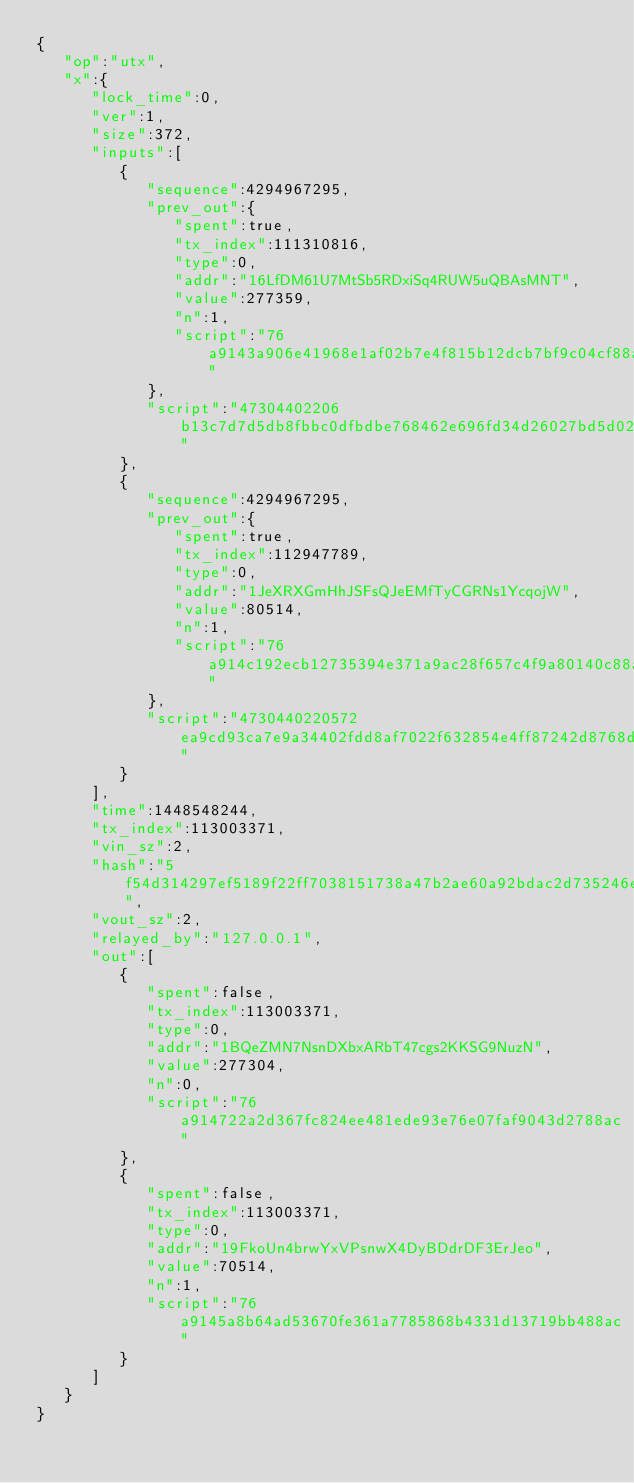Convert code to text. <code><loc_0><loc_0><loc_500><loc_500><_XML_>{
   "op":"utx",
   "x":{
      "lock_time":0,
      "ver":1,
      "size":372,
      "inputs":[
         {
            "sequence":4294967295,
            "prev_out":{
               "spent":true,
               "tx_index":111310816,
               "type":0,
               "addr":"16LfDM61U7MtSb5RDxiSq4RUW5uQBAsMNT",
               "value":277359,
               "n":1,
               "script":"76a9143a906e41968e1af02b7e4f815b12dcb7bf9c04cf88ac"
            },
            "script":"47304402206b13c7d7d5db8fbbc0dfbdbe768462e696fd34d26027bd5d0277696b37ba4ce20220377b897a3247b8359b994faf213976b1a158c52fdf916b00573c202650eef11f01210396db59908ffbd4102d9df086578235e339d7741208d17f06d04238d9a8502fca"
         },
         {
            "sequence":4294967295,
            "prev_out":{
               "spent":true,
               "tx_index":112947789,
               "type":0,
               "addr":"1JeXRXGmHhJSFsQJeEMfTyCGRNs1YcqojW",
               "value":80514,
               "n":1,
               "script":"76a914c192ecb12735394e371a9ac28f657c4f9a80140c88ac"
            },
            "script":"4730440220572ea9cd93ca7e9a34402fdd8af7022f632854e4ff87242d8768d7219729443a022067b430a8c4fef052835d3b2450e7c9f9fe0d13e66d6811fdef865c2103eb2728012102532fa5f2b33c48dd52b1deb11941e1932dd98b9f804540d515d505354305f474"
         }
      ],
      "time":1448548244,
      "tx_index":113003371,
      "vin_sz":2,
      "hash":"5f54d314297ef5189f22ff7038151738a47b2ae60a92bdac2d735246e3586144",
      "vout_sz":2,
      "relayed_by":"127.0.0.1",
      "out":[
         {
            "spent":false,
            "tx_index":113003371,
            "type":0,
            "addr":"1BQeZMN7NsnDXbxARbT47cgs2KKSG9NuzN",
            "value":277304,
            "n":0,
            "script":"76a914722a2d367fc824ee481ede93e76e07faf9043d2788ac"
         },
         {
            "spent":false,
            "tx_index":113003371,
            "type":0,
            "addr":"19FkoUn4brwYxVPsnwX4DyBDdrDF3ErJeo",
            "value":70514,
            "n":1,
            "script":"76a9145a8b64ad53670fe361a7785868b4331d13719bb488ac"
         }
      ]
   }
}</code> 